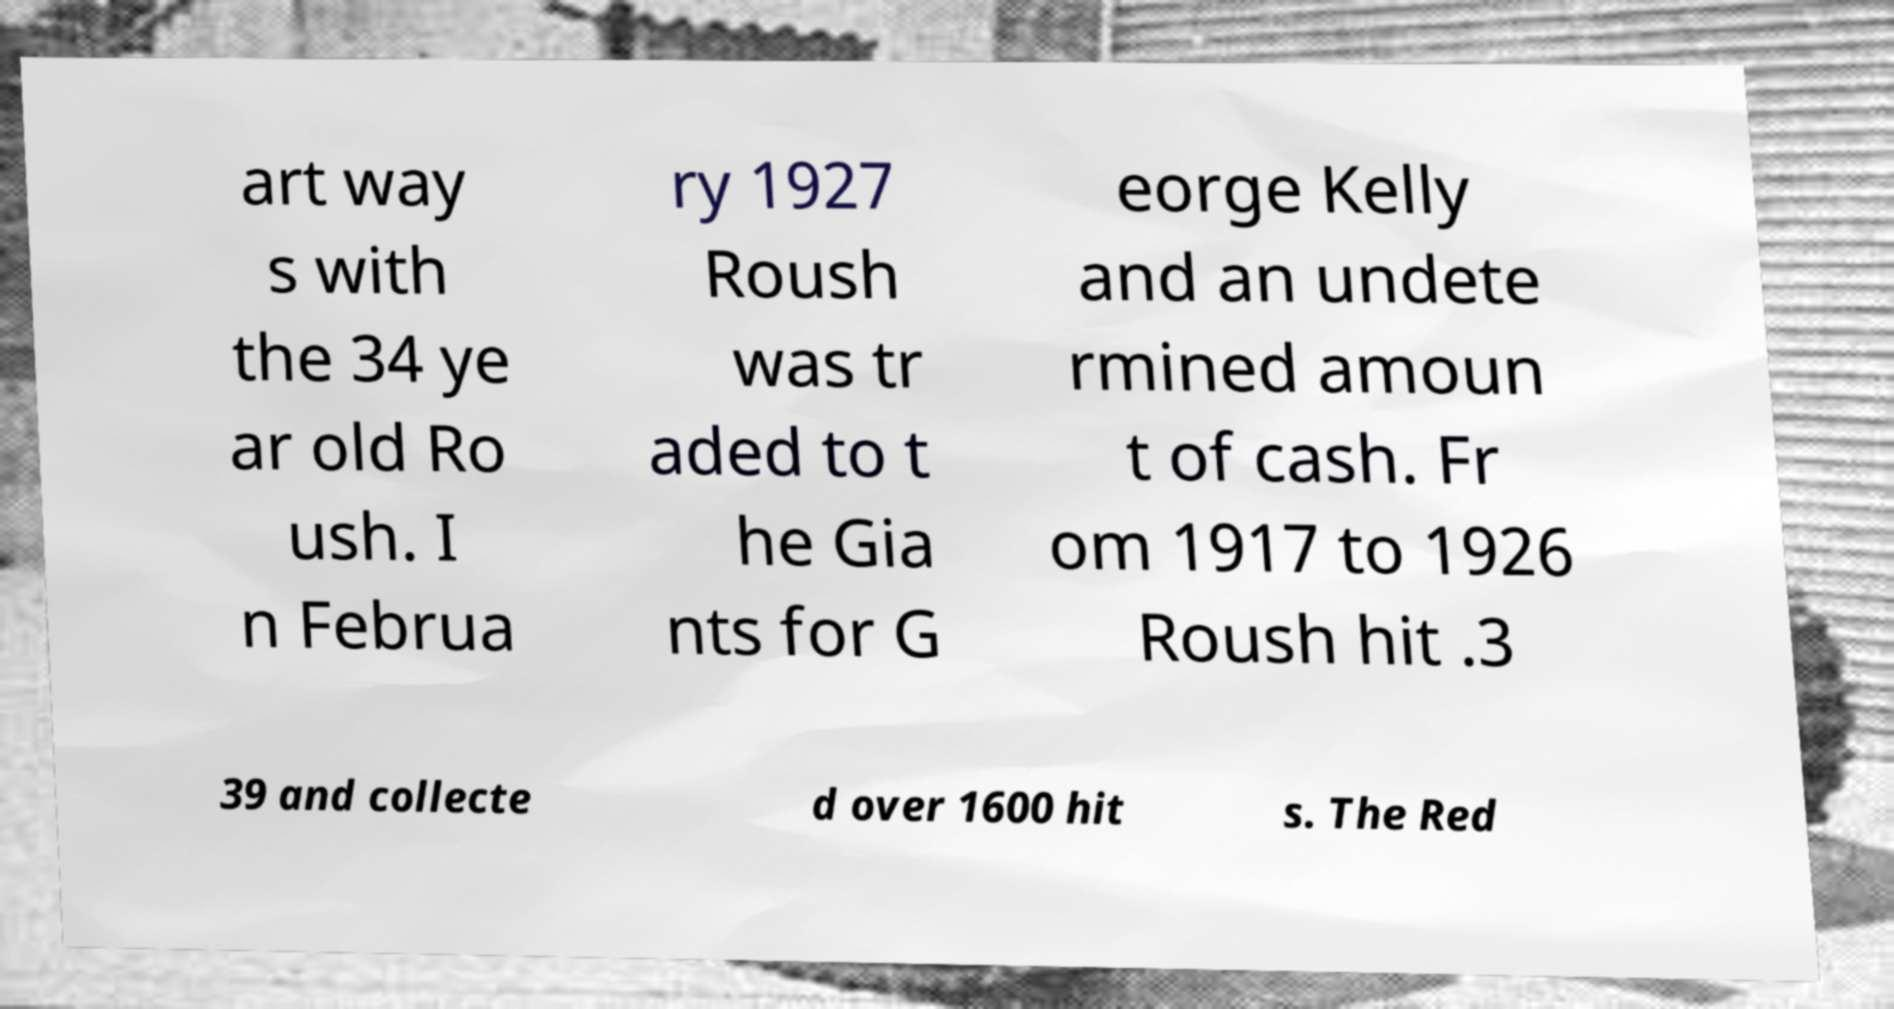Can you accurately transcribe the text from the provided image for me? art way s with the 34 ye ar old Ro ush. I n Februa ry 1927 Roush was tr aded to t he Gia nts for G eorge Kelly and an undete rmined amoun t of cash. Fr om 1917 to 1926 Roush hit .3 39 and collecte d over 1600 hit s. The Red 